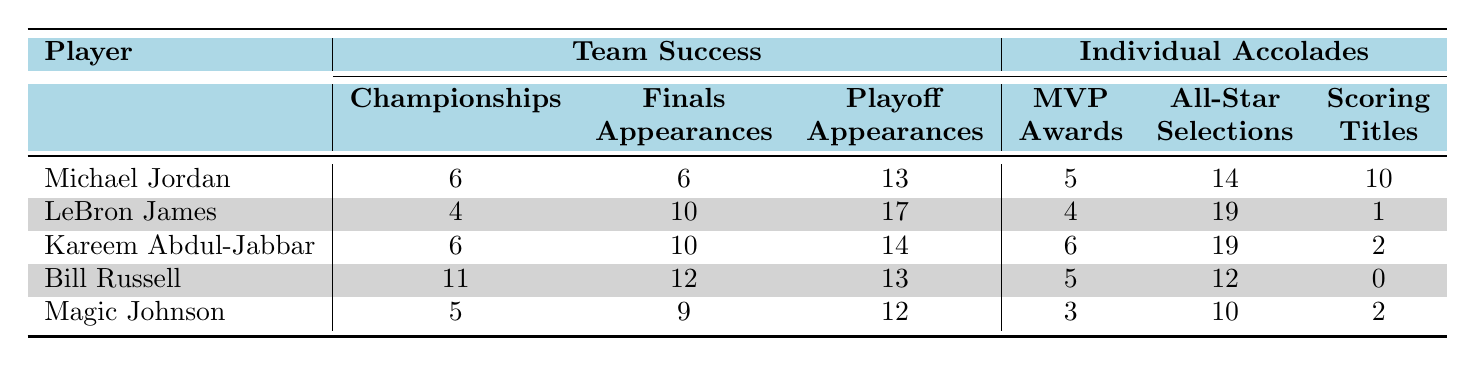What's the total number of championships won by Michael Jordan and Kareem Abdul-Jabbar? Michael Jordan has won 6 championships, and Kareem Abdul-Jabbar also has 6 championships. Adding these together gives 6 + 6 = 12 championships total.
Answer: 12 How many All-Star selections does LeBron James have compared to Bill Russell? LeBron James has 19 All-Star selections, while Bill Russell has 12. Comparing these gives us the difference of 19 - 12 = 7 more selections for LeBron.
Answer: 7 Did Bill Russell win any scoring titles during his career? The table states that Bill Russell has 0 scoring titles. Therefore, the answer is no.
Answer: No Which player has the highest number of playoff appearances? Looking at the playoff appearances, LeBron James has the highest at 17. The other players have lower numbers (Michael Jordan: 13, Kareem Abdul-Jabbar: 14, Bill Russell: 13, Magic Johnson: 12), confirming LeBron's status.
Answer: 17 Is it true that Kareem Abdul-Jabbar has more MVP awards than Magic Johnson? Kareem Abdul-Jabbar has 6 MVP awards, while Magic Johnson has 3. Since 6 is greater than 3, the statement is true.
Answer: Yes What is the average number of championships won among all listed players? The total championships won are 6 (Jordan) + 4 (James) + 6 (Abdul-Jabbar) + 11 (Russell) + 5 (Johnson) = 32 championships. There are 5 players, so the average is calculated as 32/5 = 6.4.
Answer: 6.4 Who has the highest number of finals appearances? Bill Russell has 12 finals appearances, which is the highest when looking at the other players (Michael Jordan: 6, LeBron James: 10, Kareem Abdul-Jabbar: 10, Magic Johnson: 9). So, the answer is Bill Russell.
Answer: Bill Russell How many scoring titles do Michael Jordan and Magic Johnson have combined? Michael Jordan has 10 scoring titles and Magic Johnson has 2. Adding these values gives us 10 + 2 = 12 combined scoring titles.
Answer: 12 Has any player in the table won more than 10 championships? The table shows that Bill Russell has 11 championships, which is more than 10. Thus, the answer is yes.
Answer: Yes 